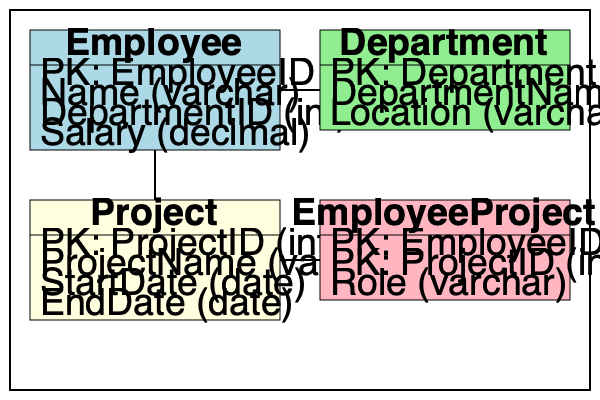Given the database schema representation above, identify a potential optimization to improve data integrity and reduce redundancy. Explain your reasoning and propose a specific change to the schema. To optimize this database schema, we need to analyze the relationships between tables and identify any potential issues with data integrity or redundancy. Let's go through the analysis step-by-step:

1. Examine the relationships:
   - Employee to Department: Many-to-One (Many employees can belong to one department)
   - Employee to Project: Many-to-Many (through EmployeeProject junction table)
   - Department to Project: No direct relationship

2. Identify potential issues:
   - The Employee table has a DepartmentID column, which is a foreign key to the Department table. This is correct and maintains referential integrity.
   - The EmployeeProject table serves as a junction table for the Many-to-Many relationship between Employee and Project. This is a good practice.

3. Spot the optimization opportunity:
   - The Project table doesn't have any connection to the Department table.
   - In real-world scenarios, projects are often associated with specific departments.

4. Propose an optimization:
   - Add a DepartmentID column to the Project table as a foreign key referencing the Department table.
   - This change would establish a relationship between projects and departments, allowing for better data organization and reporting capabilities.

5. Benefits of the proposed change:
   - Improved data integrity: Ensures that each project is associated with a valid department.
   - Enhanced querying capabilities: Enables easier retrieval of projects by department.
   - Better representation of real-world relationships: Reflects the common business structure where projects are often department-specific.

6. Implementation:
   - Add a new column "DepartmentID (int)" to the Project table.
   - Set up a foreign key constraint on this new column referencing the DepartmentID in the Department table.

This optimization improves the overall structure of the database schema by establishing a logical connection between projects and departments, which was previously missing.
Answer: Add DepartmentID (int) as a foreign key to the Project table, referencing the Department table. 